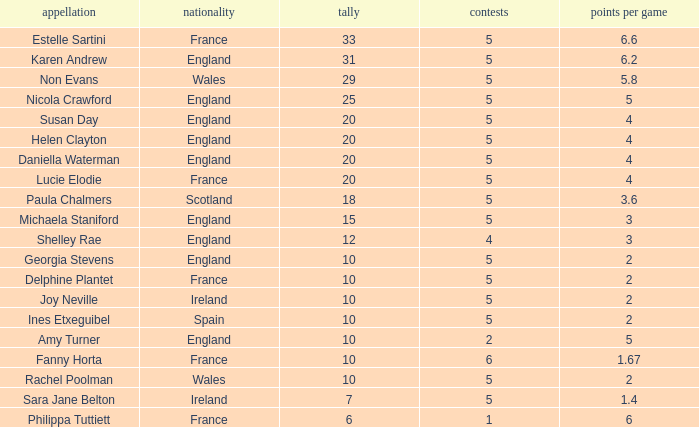Could you parse the entire table? {'header': ['appellation', 'nationality', 'tally', 'contests', 'points per game'], 'rows': [['Estelle Sartini', 'France', '33', '5', '6.6'], ['Karen Andrew', 'England', '31', '5', '6.2'], ['Non Evans', 'Wales', '29', '5', '5.8'], ['Nicola Crawford', 'England', '25', '5', '5'], ['Susan Day', 'England', '20', '5', '4'], ['Helen Clayton', 'England', '20', '5', '4'], ['Daniella Waterman', 'England', '20', '5', '4'], ['Lucie Elodie', 'France', '20', '5', '4'], ['Paula Chalmers', 'Scotland', '18', '5', '3.6'], ['Michaela Staniford', 'England', '15', '5', '3'], ['Shelley Rae', 'England', '12', '4', '3'], ['Georgia Stevens', 'England', '10', '5', '2'], ['Delphine Plantet', 'France', '10', '5', '2'], ['Joy Neville', 'Ireland', '10', '5', '2'], ['Ines Etxeguibel', 'Spain', '10', '5', '2'], ['Amy Turner', 'England', '10', '2', '5'], ['Fanny Horta', 'France', '10', '6', '1.67'], ['Rachel Poolman', 'Wales', '10', '5', '2'], ['Sara Jane Belton', 'Ireland', '7', '5', '1.4'], ['Philippa Tuttiett', 'France', '6', '1', '6']]} Can you tell me the lowest Pts/game that has the Games larger than 6? None. 